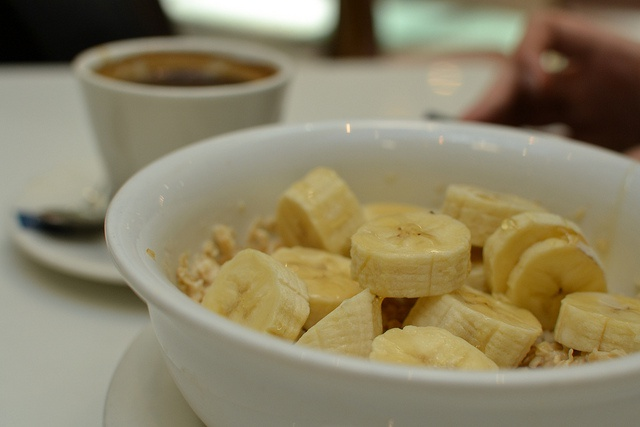Describe the objects in this image and their specific colors. I can see bowl in black, tan, darkgray, olive, and gray tones, banana in black, tan, and olive tones, cup in black, gray, and olive tones, and spoon in black, darkgreen, and gray tones in this image. 